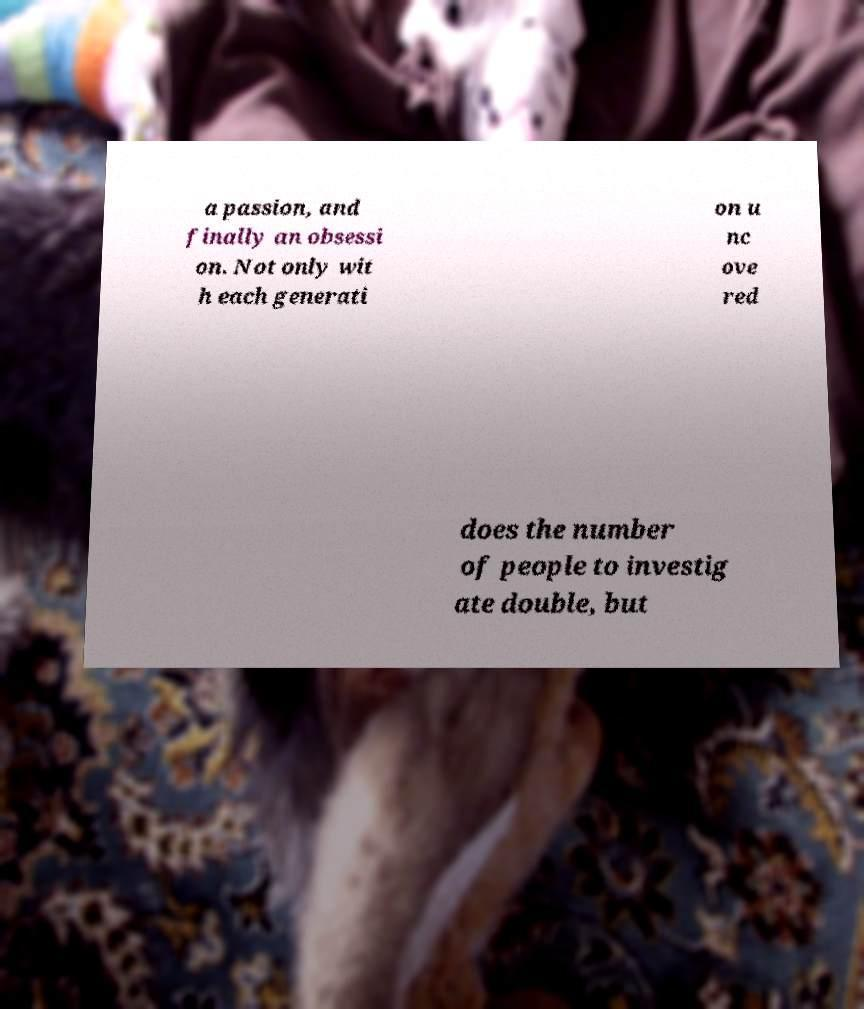Please identify and transcribe the text found in this image. a passion, and finally an obsessi on. Not only wit h each generati on u nc ove red does the number of people to investig ate double, but 